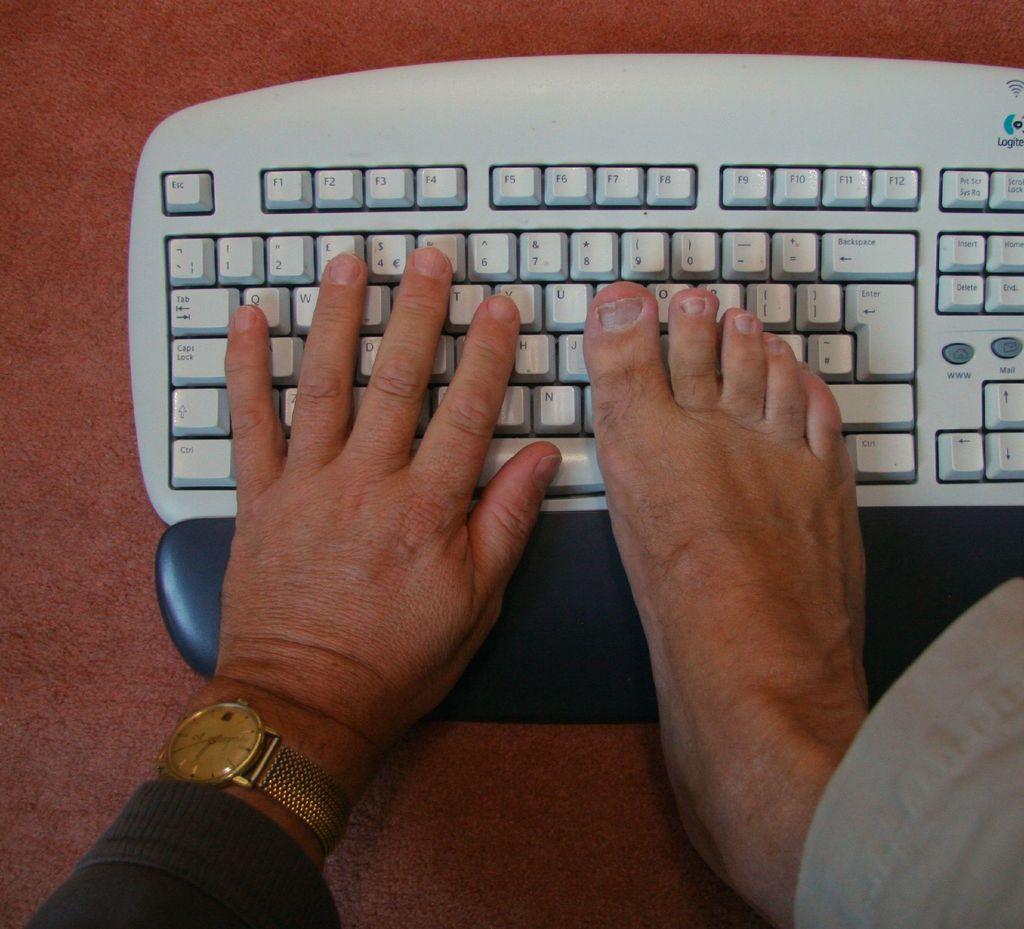Is the keyboard for a computer?
Keep it short and to the point. Answering does not require reading text in the image. What key is on the top left of the keyboard?
Make the answer very short. Esc. 